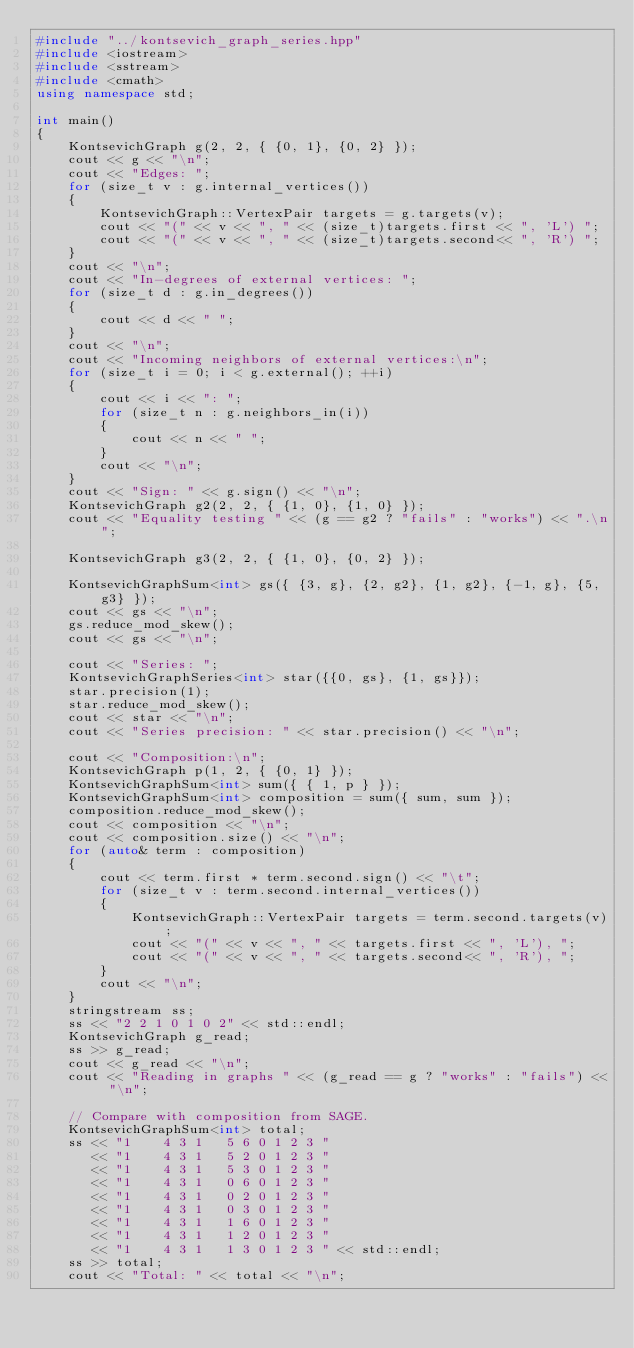Convert code to text. <code><loc_0><loc_0><loc_500><loc_500><_C++_>#include "../kontsevich_graph_series.hpp"
#include <iostream>
#include <sstream>
#include <cmath>
using namespace std;

int main()
{
    KontsevichGraph g(2, 2, { {0, 1}, {0, 2} });
    cout << g << "\n";
    cout << "Edges: ";
    for (size_t v : g.internal_vertices())
    {
        KontsevichGraph::VertexPair targets = g.targets(v);
        cout << "(" << v << ", " << (size_t)targets.first << ", 'L') ";
        cout << "(" << v << ", " << (size_t)targets.second<< ", 'R') ";
    }
    cout << "\n";
    cout << "In-degrees of external vertices: ";
    for (size_t d : g.in_degrees())
    {
        cout << d << " ";
    }
    cout << "\n";
    cout << "Incoming neighbors of external vertices:\n";
    for (size_t i = 0; i < g.external(); ++i)
    {
        cout << i << ": ";
        for (size_t n : g.neighbors_in(i))
        {
            cout << n << " ";
        }
        cout << "\n";
    }
    cout << "Sign: " << g.sign() << "\n";
    KontsevichGraph g2(2, 2, { {1, 0}, {1, 0} });
    cout << "Equality testing " << (g == g2 ? "fails" : "works") << ".\n";

    KontsevichGraph g3(2, 2, { {1, 0}, {0, 2} });

    KontsevichGraphSum<int> gs({ {3, g}, {2, g2}, {1, g2}, {-1, g}, {5, g3} });
    cout << gs << "\n";
    gs.reduce_mod_skew();
    cout << gs << "\n";

    cout << "Series: ";
    KontsevichGraphSeries<int> star({{0, gs}, {1, gs}});
    star.precision(1);
    star.reduce_mod_skew();
    cout << star << "\n";
    cout << "Series precision: " << star.precision() << "\n";

    cout << "Composition:\n";
    KontsevichGraph p(1, 2, { {0, 1} });
    KontsevichGraphSum<int> sum({ { 1, p } });
    KontsevichGraphSum<int> composition = sum({ sum, sum });
    composition.reduce_mod_skew();
    cout << composition << "\n";
    cout << composition.size() << "\n";
    for (auto& term : composition)
    {
        cout << term.first * term.second.sign() << "\t";
        for (size_t v : term.second.internal_vertices())
        {
            KontsevichGraph::VertexPair targets = term.second.targets(v);
            cout << "(" << v << ", " << targets.first << ", 'L'), ";
            cout << "(" << v << ", " << targets.second<< ", 'R'), ";
        }
        cout << "\n";
    }
    stringstream ss;
    ss << "2 2 1 0 1 0 2" << std::endl;
    KontsevichGraph g_read;
    ss >> g_read;
    cout << g_read << "\n";
    cout << "Reading in graphs " << (g_read == g ? "works" : "fails") << "\n";

    // Compare with composition from SAGE.
    KontsevichGraphSum<int> total;
    ss << "1 	4 3 1 	5 6	0 1	2 3 "
       << "1 	4 3 1 	5 2	0 1	2 3 "
       << "1 	4 3 1 	5 3	0 1	2 3 "
       << "1 	4 3 1 	0 6	0 1	2 3 "
       << "1 	4 3 1 	0 2	0 1	2 3 "
       << "1 	4 3 1 	0 3	0 1	2 3 "
       << "1 	4 3 1 	1 6	0 1	2 3 "
       << "1 	4 3 1 	1 2	0 1	2 3 "
       << "1 	4 3 1 	1 3	0 1	2 3 " << std::endl;
    ss >> total;
    cout << "Total: " << total << "\n";</code> 